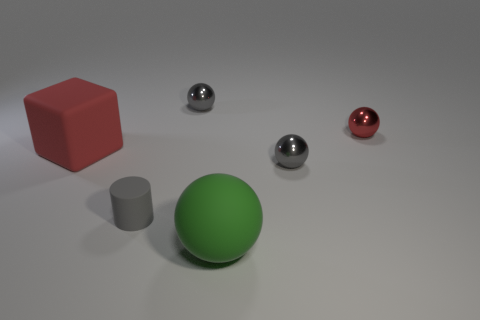Subtract all cyan cylinders. How many gray balls are left? 2 Subtract all tiny balls. How many balls are left? 1 Add 2 big green rubber spheres. How many objects exist? 8 Subtract all green spheres. How many spheres are left? 3 Subtract all balls. How many objects are left? 2 Subtract all brown spheres. Subtract all green blocks. How many spheres are left? 4 Subtract all gray things. Subtract all large red rubber blocks. How many objects are left? 2 Add 6 tiny rubber objects. How many tiny rubber objects are left? 7 Add 5 large cyan cylinders. How many large cyan cylinders exist? 5 Subtract 0 yellow cylinders. How many objects are left? 6 